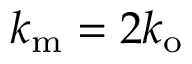Convert formula to latex. <formula><loc_0><loc_0><loc_500><loc_500>k _ { m } = 2 k _ { o }</formula> 